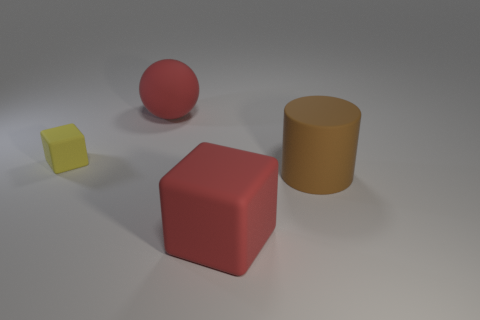What material is the large object that is the same color as the big rubber ball?
Your response must be concise. Rubber. What color is the other cube that is the same material as the yellow block?
Offer a very short reply. Red. The big matte object that is to the left of the cube that is in front of the large cylinder is what color?
Give a very brief answer. Red. Are there any shiny cylinders of the same color as the large rubber cube?
Provide a short and direct response. No. What shape is the brown rubber thing that is the same size as the red rubber ball?
Provide a short and direct response. Cylinder. There is a matte block that is left of the big red block; what number of blocks are behind it?
Ensure brevity in your answer.  0. Is the color of the big matte sphere the same as the big matte cylinder?
Provide a succinct answer. No. What number of other objects are there of the same material as the big brown cylinder?
Ensure brevity in your answer.  3. What shape is the red matte object that is to the left of the big red rubber thing that is in front of the yellow rubber object?
Ensure brevity in your answer.  Sphere. How big is the red thing that is behind the tiny rubber block?
Your answer should be very brief. Large. 